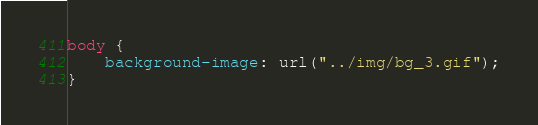Convert code to text. <code><loc_0><loc_0><loc_500><loc_500><_CSS_>body {
    background-image: url("../img/bg_3.gif");
}</code> 